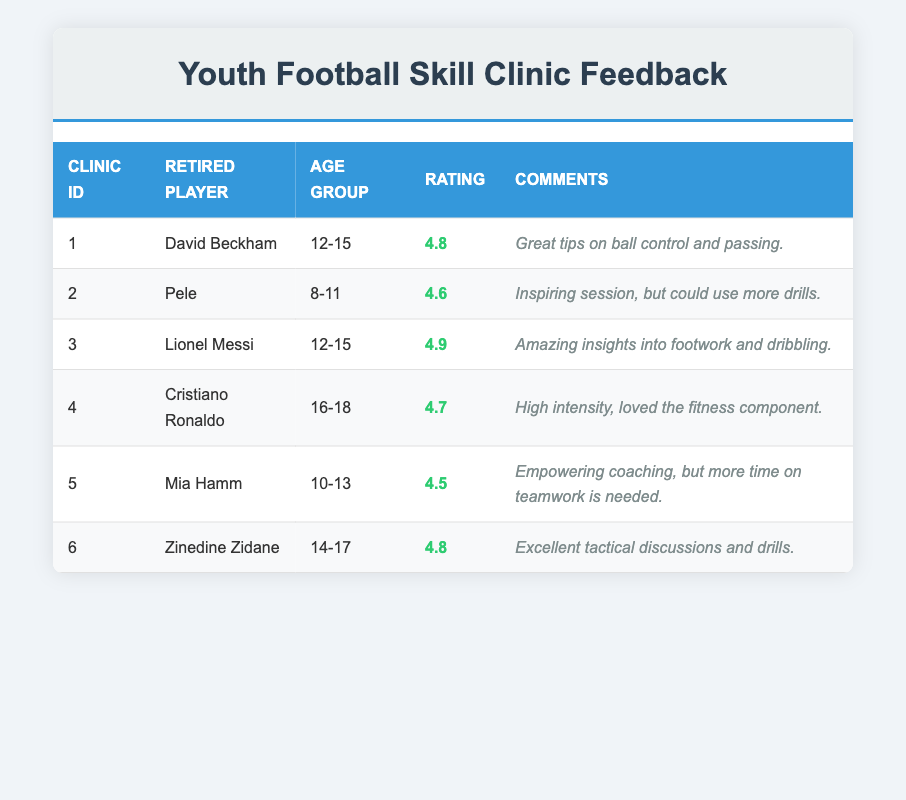What is the highest feedback rating, and which retired player received it? The table shows that Lionel Messi received the highest feedback rating of 4.9 for his clinic. This is the highest value found in the "Rating" column.
Answer: 4.9, Lionel Messi Which retired player conducted a skill clinic for the age group 10-13? Mia Hamm is the retired player who conducted the clinic specifically for the age group 10-13, as listed in the "Age Group" column.
Answer: Mia Hamm What is the average feedback rating for all the skill clinics? To find the average, sum all the feedback ratings: (4.8 + 4.6 + 4.9 + 4.7 + 4.5 + 4.8) = 28.3. There are 6 clinics, so the average rating is 28.3/6 = 4.7167. Rounding it gives approximately 4.72.
Answer: 4.72 Did any retired player score a feedback rating below 4.5? Reviewing the data, all feedback ratings are above 4.5, confirming that no player received a rating below this threshold.
Answer: No Which retired player received feedback related to tactical discussions? Zinedine Zidane is the retired player noted for the "Excellent tactical discussions and drills" comment, indicating he received feedback specifically related to tactical training.
Answer: Zinedine Zidane 